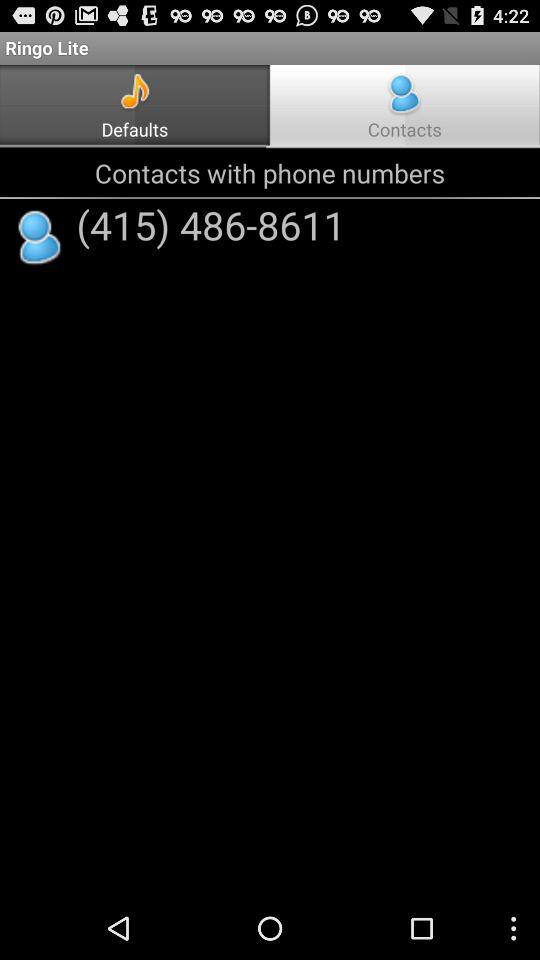Which tab is selected? The selected tab is "Contacts". 